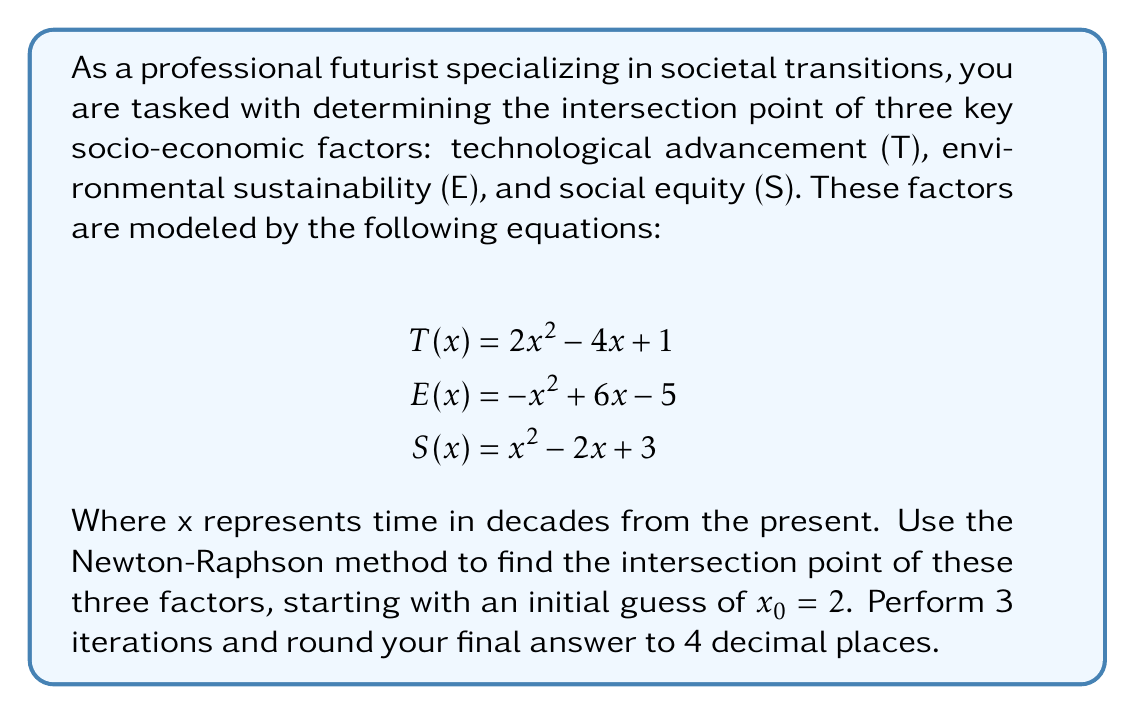Provide a solution to this math problem. To solve this problem, we need to find the root of the function $f(x) = T(x) - E(x) = T(x) - S(x) = E(x) - S(x) = 0$. We'll use $f(x) = T(x) - E(x)$ for our calculations.

1. Define the function and its derivative:
   $$f(x) = T(x) - E(x) = (2x^2 - 4x + 1) - (-x^2 + 6x - 5) = 3x^2 - 10x + 6$$
   $$f'(x) = 6x - 10$$

2. Newton-Raphson formula:
   $$x_{n+1} = x_n - \frac{f(x_n)}{f'(x_n)}$$

3. Iteration 1:
   $$f(2) = 3(2)^2 - 10(2) + 6 = 2$$
   $$f'(2) = 6(2) - 10 = 2$$
   $$x_1 = 2 - \frac{2}{2} = 1$$

4. Iteration 2:
   $$f(1) = 3(1)^2 - 10(1) + 6 = -1$$
   $$f'(1) = 6(1) - 10 = -4$$
   $$x_2 = 1 - \frac{-1}{-4} = 0.75$$

5. Iteration 3:
   $$f(0.75) = 3(0.75)^2 - 10(0.75) + 6 = 0.1875$$
   $$f'(0.75) = 6(0.75) - 10 = -5.5$$
   $$x_3 = 0.75 - \frac{0.1875}{-5.5} \approx 0.7841$$

The final result after 3 iterations, rounded to 4 decimal places, is 0.7841.
Answer: 0.7841 